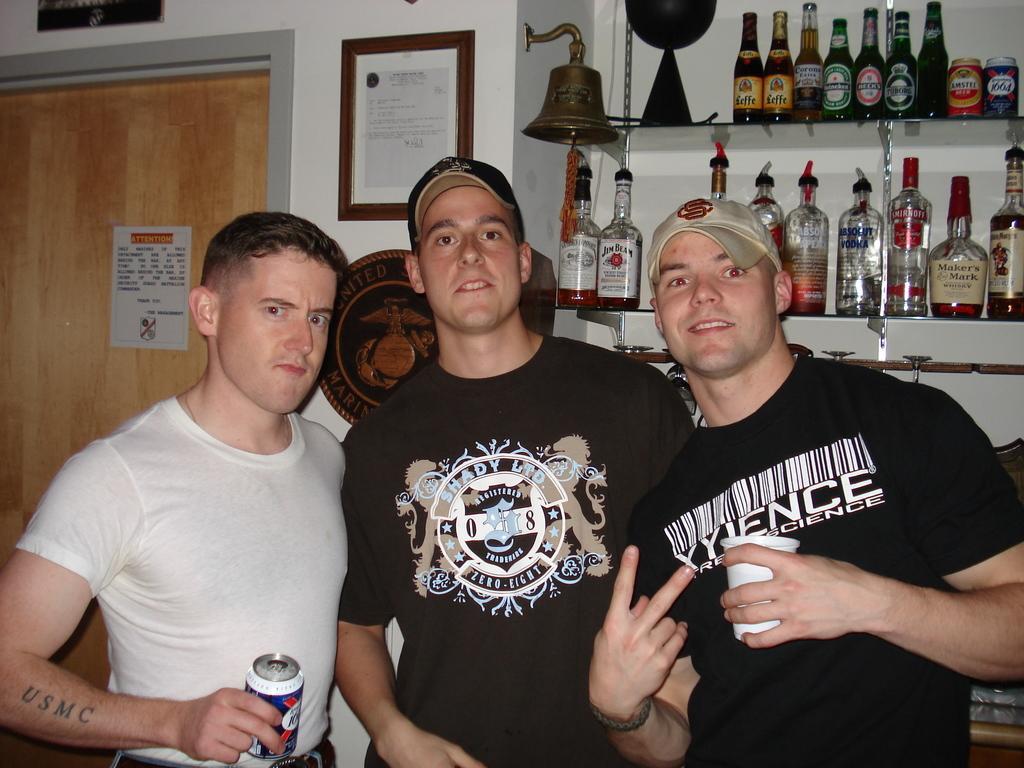Could you give a brief overview of what you see in this image? There are men standing in the center of the image and there are bottles, door, frame, poster and bell in the background area. 